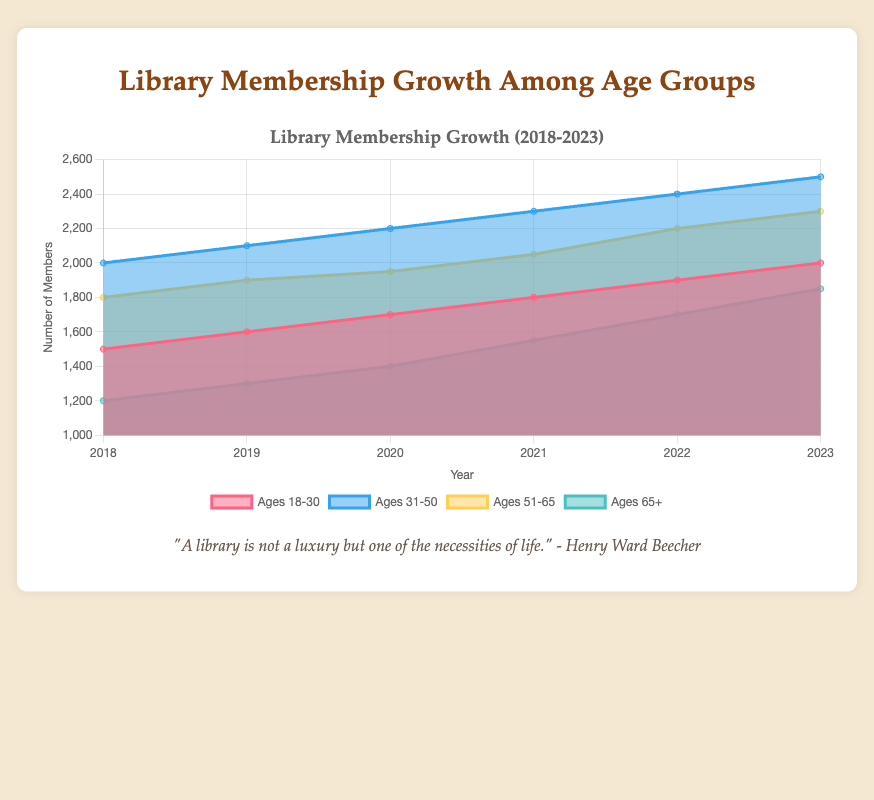what is the title of the figure? The title of the figure is prominently displayed at the top of the chart and reads "Library Membership Growth (2018-2023)"
Answer: Library Membership Growth (2018-2023) which age group had the highest number of members in 2020? To find the age group with the highest number of members in 2020, compare the data points for all age groups at the year 2020. Ages 31-50 has 2200 members, which is the highest.
Answer: Ages 31-50 how did the membership for ages 65+ change from 2018 to 2023? To determine the change in membership for ages 65+ from 2018 to 2023, subtract the number of members in 2018 from the number of members in 2023 (1850 - 1200).
Answer: Increased by 650 which year saw the largest increase in memberships for ages 51-65? Check the annual increase for ages 51-65 by subtracting the previous year's data. The largest increase is between 2021 and 2022, from 2050 to 2200 (2200 - 2050 = 150).
Answer: 2022 what is the overall trend in library memberships among elderly readers (65+) from 2018 to 2023? Observe the data points for ages 65+ from 2018 to 2023. Memberships steadily increase each year.
Answer: Steady increase how many total members were there in 2023 across all age groups? Sum the number of members for all age groups in 2023: 2000 + 2500 + 2300 + 1850 = 8650.
Answer: 8650 which age group had the smallest growth in membership from 2018 to 2023? Calculate the difference in membership for each age group from 2018 to 2023, and compare. Ages 18-30 increased from 1500 to 2000, which is 500, the smallest growth.
Answer: Ages 18-30 how does the growth trend of ages 65+ compare to ages 31-50 from 2018 to 2023? Ages 65+ increased from 1200 to 1850, an increase of 650. Ages 31-50 increased from 2000 to 2500, an increase of 500. Ages 65+ had a higher growth.
Answer: Ages 65+ had higher growth 